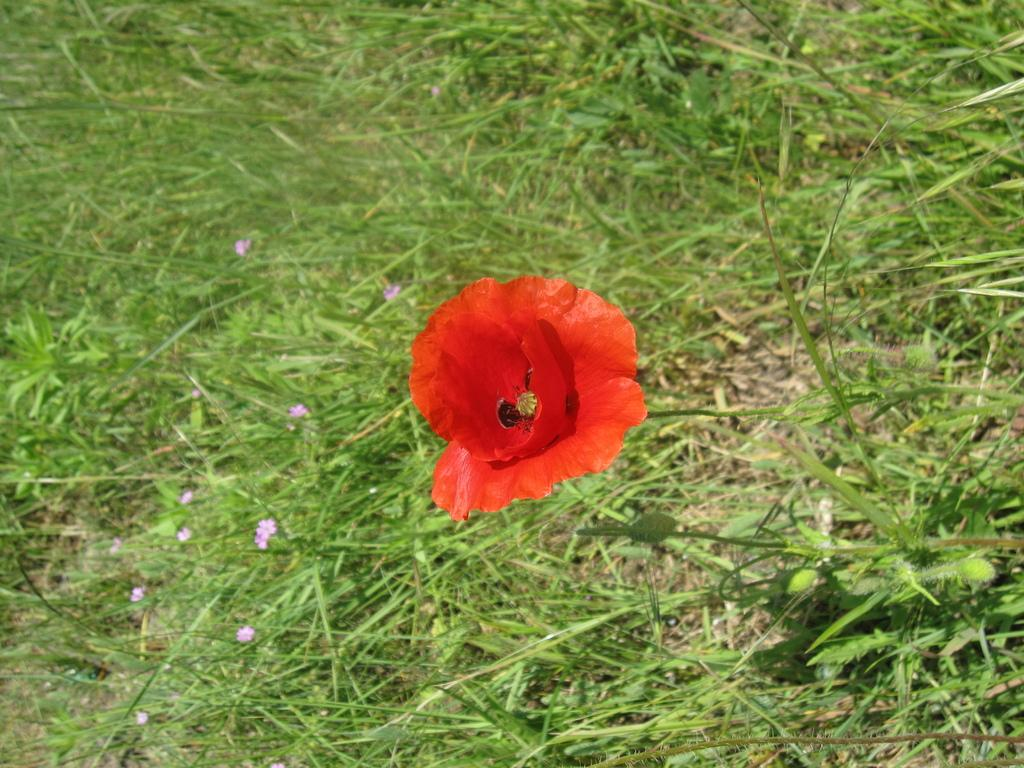What is the main subject of the image? There is a red color flower in the center of the image. What can be seen surrounding the main subject? There is greenery around the area of the image. Can you tell me how many stitches are used to create the horse in the image? There is no horse present in the image, and therefore no stitches can be counted. 